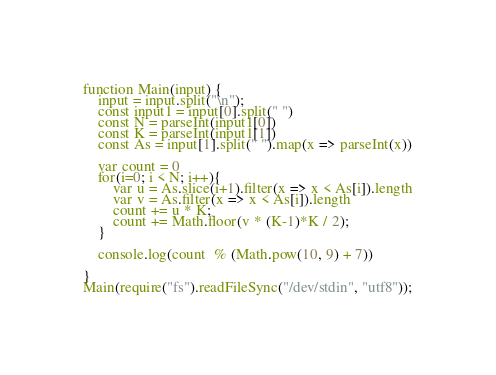<code> <loc_0><loc_0><loc_500><loc_500><_JavaScript_>function Main(input) {
	input = input.split("\n");
	const input1 = input[0].split(" ")
	const N = parseInt(input1[0])
	const K = parseInt(input1[1])
	const As = input[1].split(" ").map(x => parseInt(x))

	var count = 0
	for(i=0; i < N; i++){
		var u = As.slice(i+1).filter(x => x < As[i]).length
		var v = As.filter(x => x < As[i]).length
		count += u * K;
		count += Math.floor(v * (K-1)*K / 2);
	}

	console.log(count  % (Math.pow(10, 9) + 7))

}
Main(require("fs").readFileSync("/dev/stdin", "utf8"));</code> 